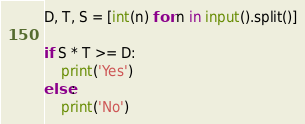Convert code to text. <code><loc_0><loc_0><loc_500><loc_500><_Python_>D, T, S = [int(n) for n in input().split()]

if S * T >= D:
    print('Yes')
else:
    print('No')
</code> 